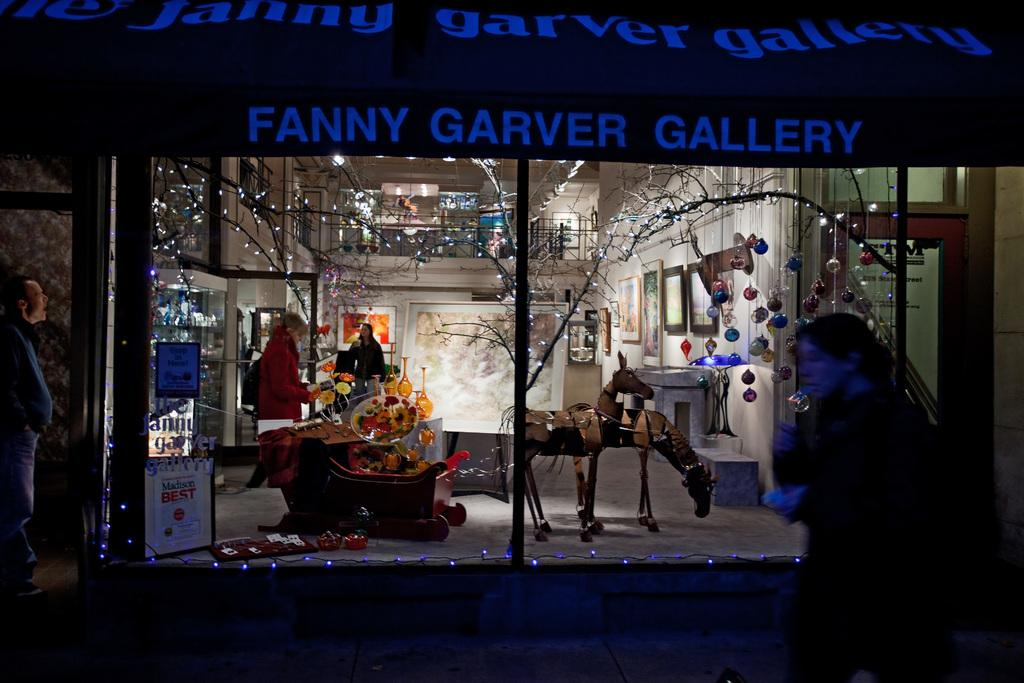What type of wall is featured in the image? There is a framed glass wall in the image. What can be seen outside the glass wall? Trees decorated with string lights are present in the image. What else is visible in the image besides the glass wall and trees? There are other objects in the image. Can you describe the board with writing in the image? Yes, there is a board with writing in the image. What type of thread is used to create the prose on the representative board in the image? There is no thread, prose, or representative board present in the image. 